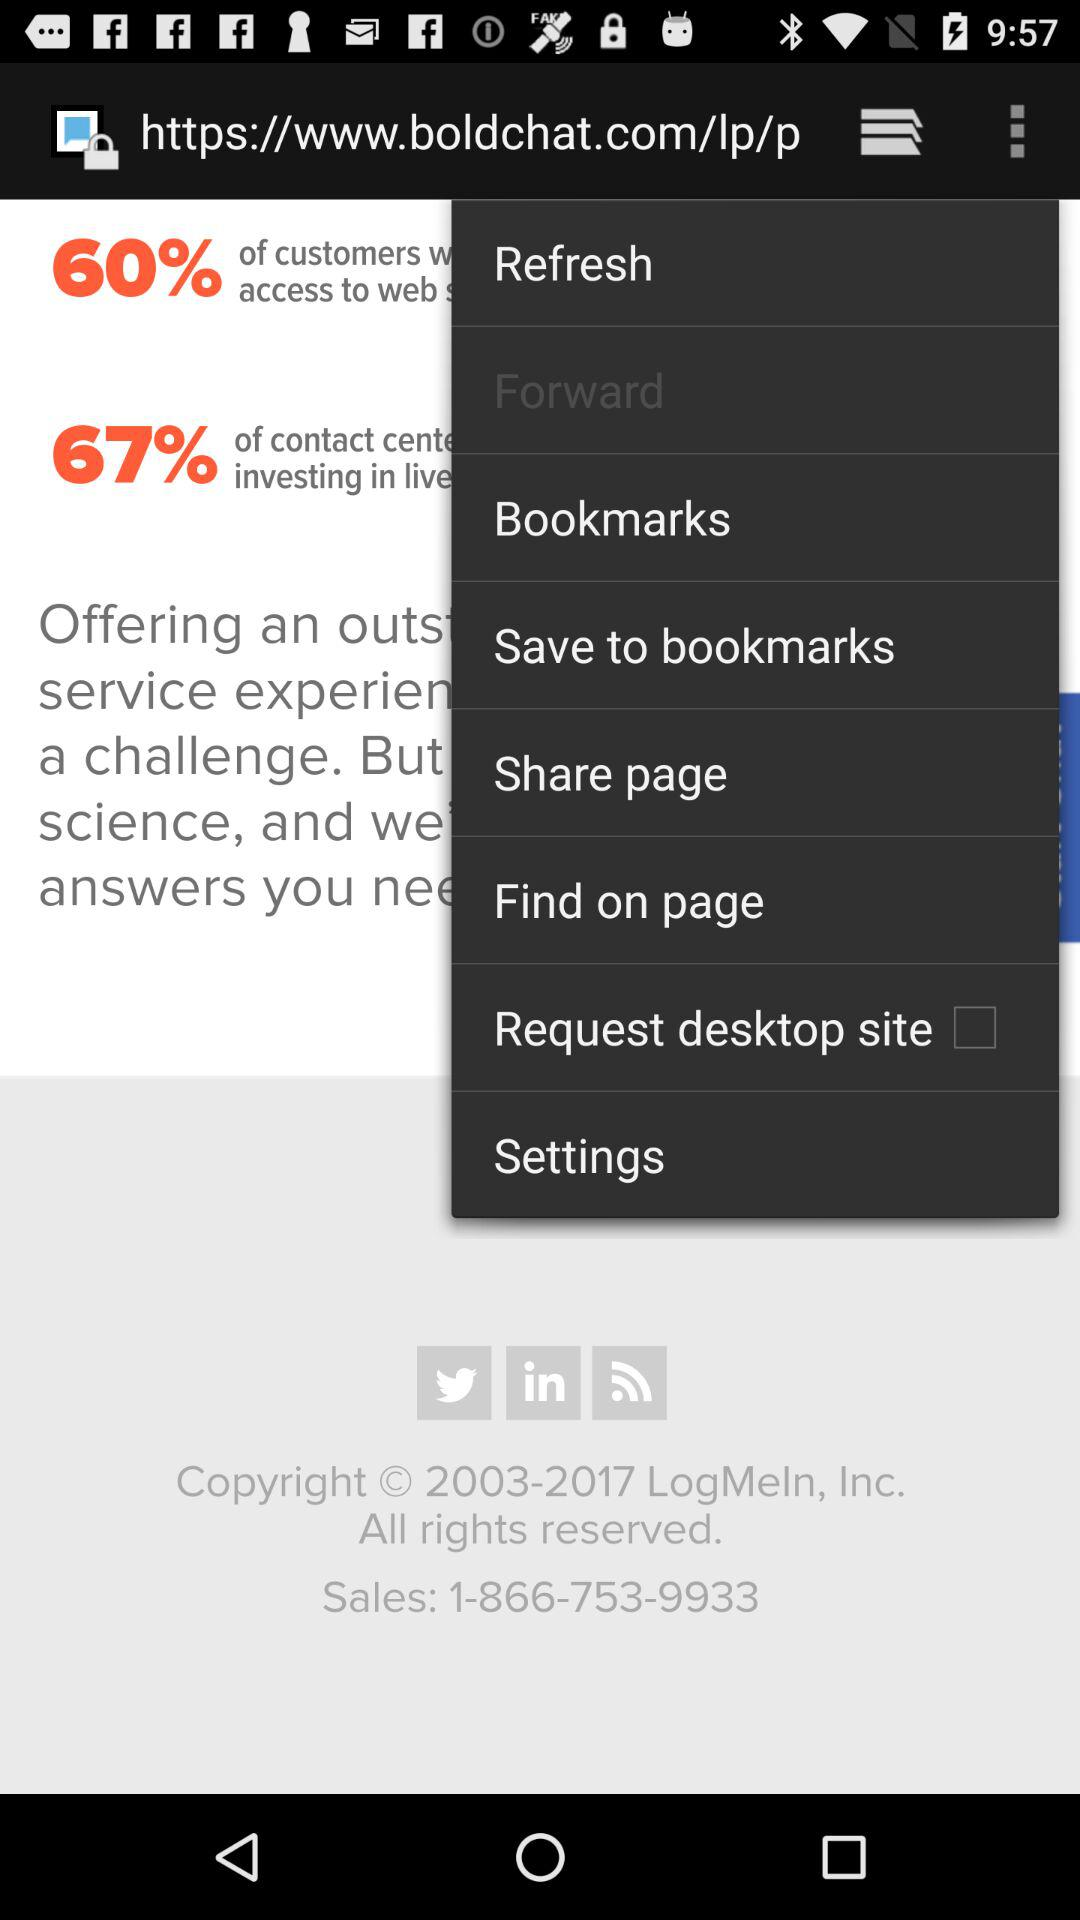What is the given sales number on the screen? The given sales number is 1-866-753-9933. 